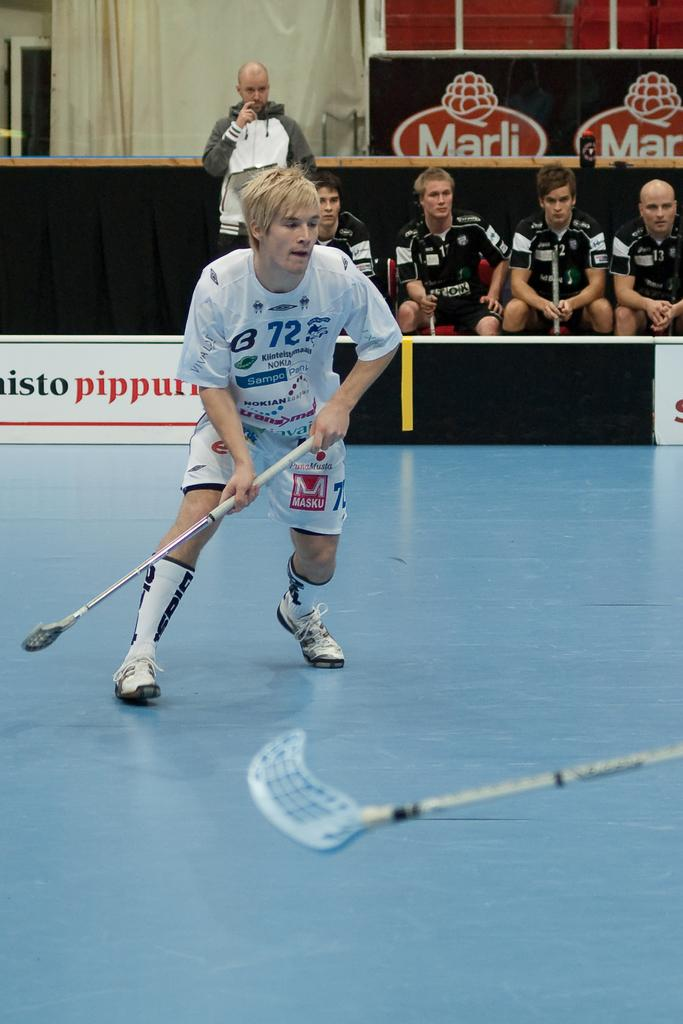What is the man in the image holding? The man is holding a stick in the image. Where is the stick located in relation to the man? The stick is visible on the right side of the image. What are the other people in the image doing? There are four people sitting in the background of the background of the image. What is the position of the man in the image? The man is standing in the image. What can be seen in the background of the image besides the people? There is a curtain in the background of the image. What type of coat is the man wearing in the image? There is no coat visible in the image; the man is holding a stick and standing. 